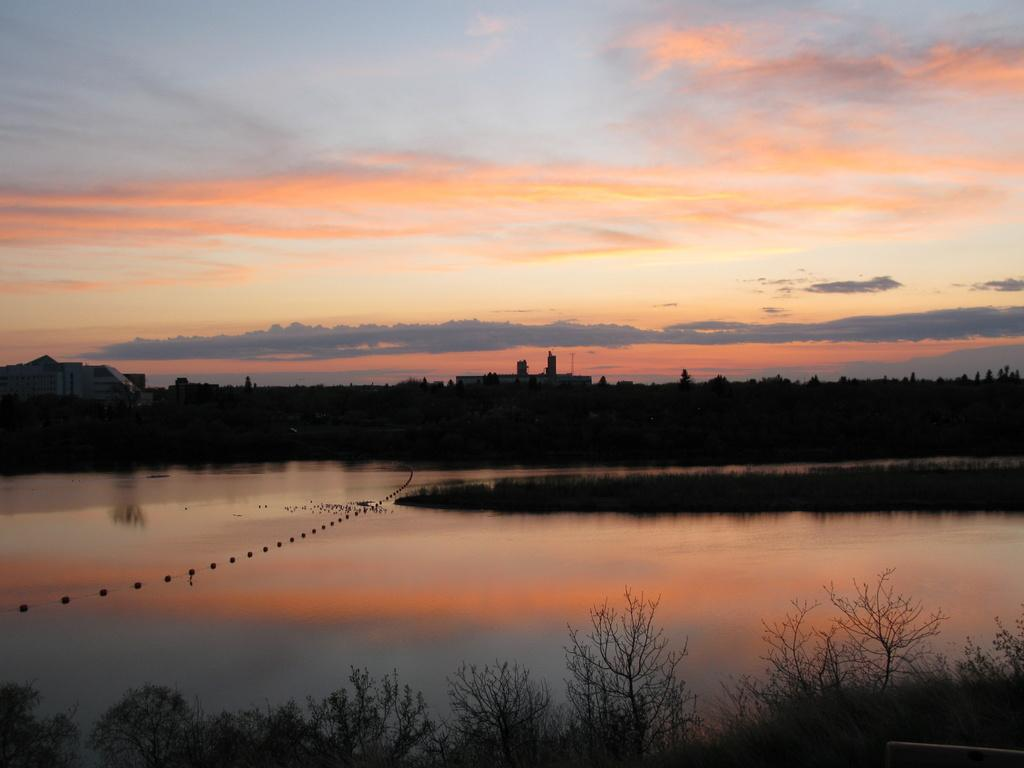What can be seen in the sky in the image? The sky is visible in the image. Are there any weather conditions depicted in the image? Yes, there are clouds in the image. What type of vegetation is present in the image? There are trees in the image. What natural element is visible in the image besides the sky and trees? There is water visible in the image. What type of oil can be seen dripping from the trees in the image? There is no oil present in the image; it features the sky, clouds, trees, and water. 